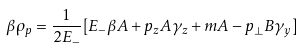Convert formula to latex. <formula><loc_0><loc_0><loc_500><loc_500>\beta \rho _ { p } = \frac { 1 } { 2 E _ { - } } [ E _ { - } \beta A + p _ { z } A \gamma _ { z } + m A - p _ { \perp } B \gamma _ { y } ]</formula> 